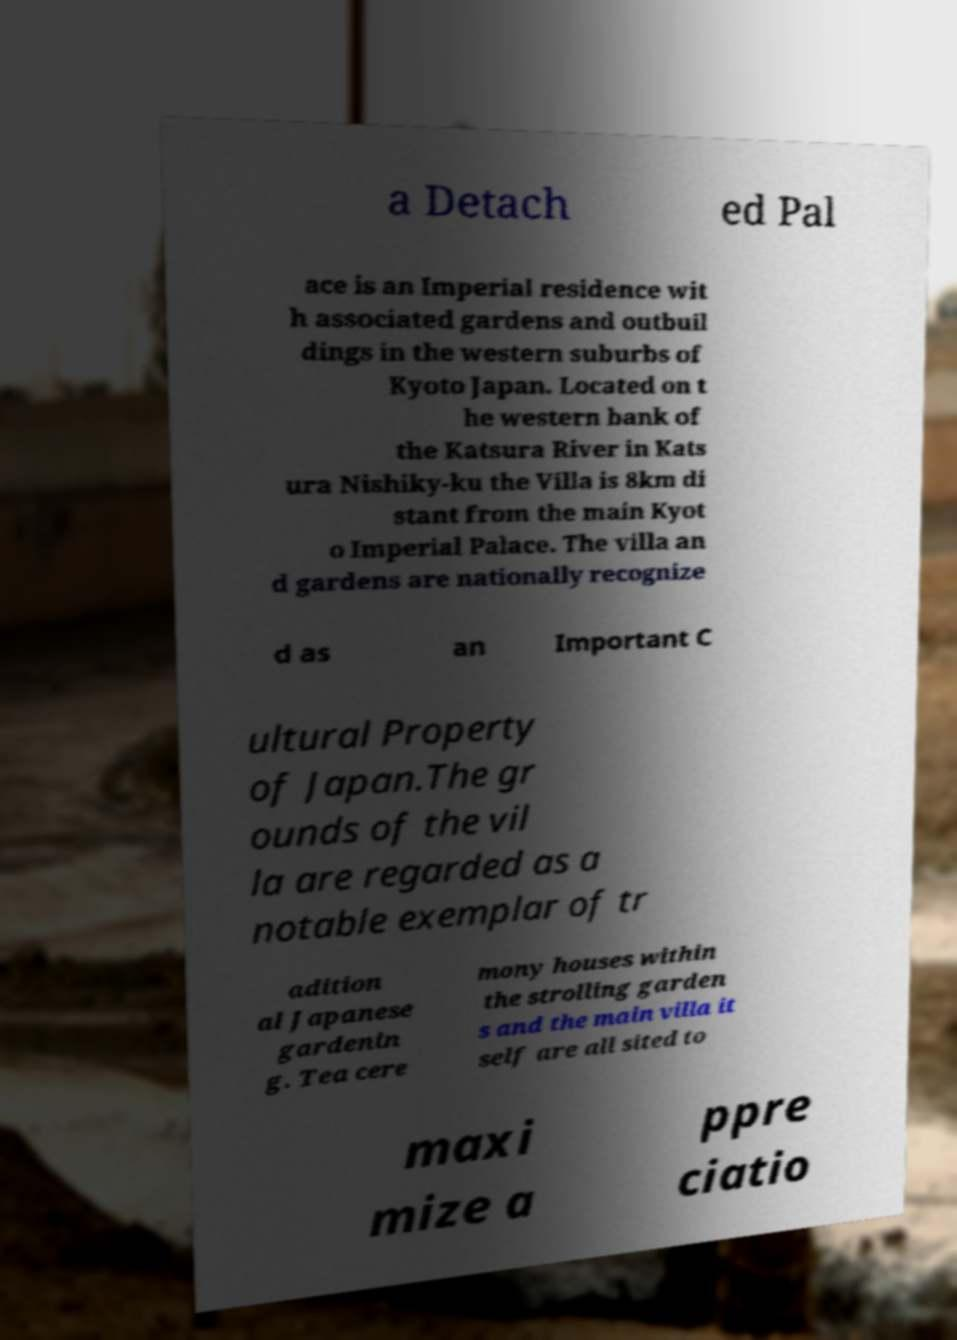Could you assist in decoding the text presented in this image and type it out clearly? a Detach ed Pal ace is an Imperial residence wit h associated gardens and outbuil dings in the western suburbs of Kyoto Japan. Located on t he western bank of the Katsura River in Kats ura Nishiky-ku the Villa is 8km di stant from the main Kyot o Imperial Palace. The villa an d gardens are nationally recognize d as an Important C ultural Property of Japan.The gr ounds of the vil la are regarded as a notable exemplar of tr adition al Japanese gardenin g. Tea cere mony houses within the strolling garden s and the main villa it self are all sited to maxi mize a ppre ciatio 